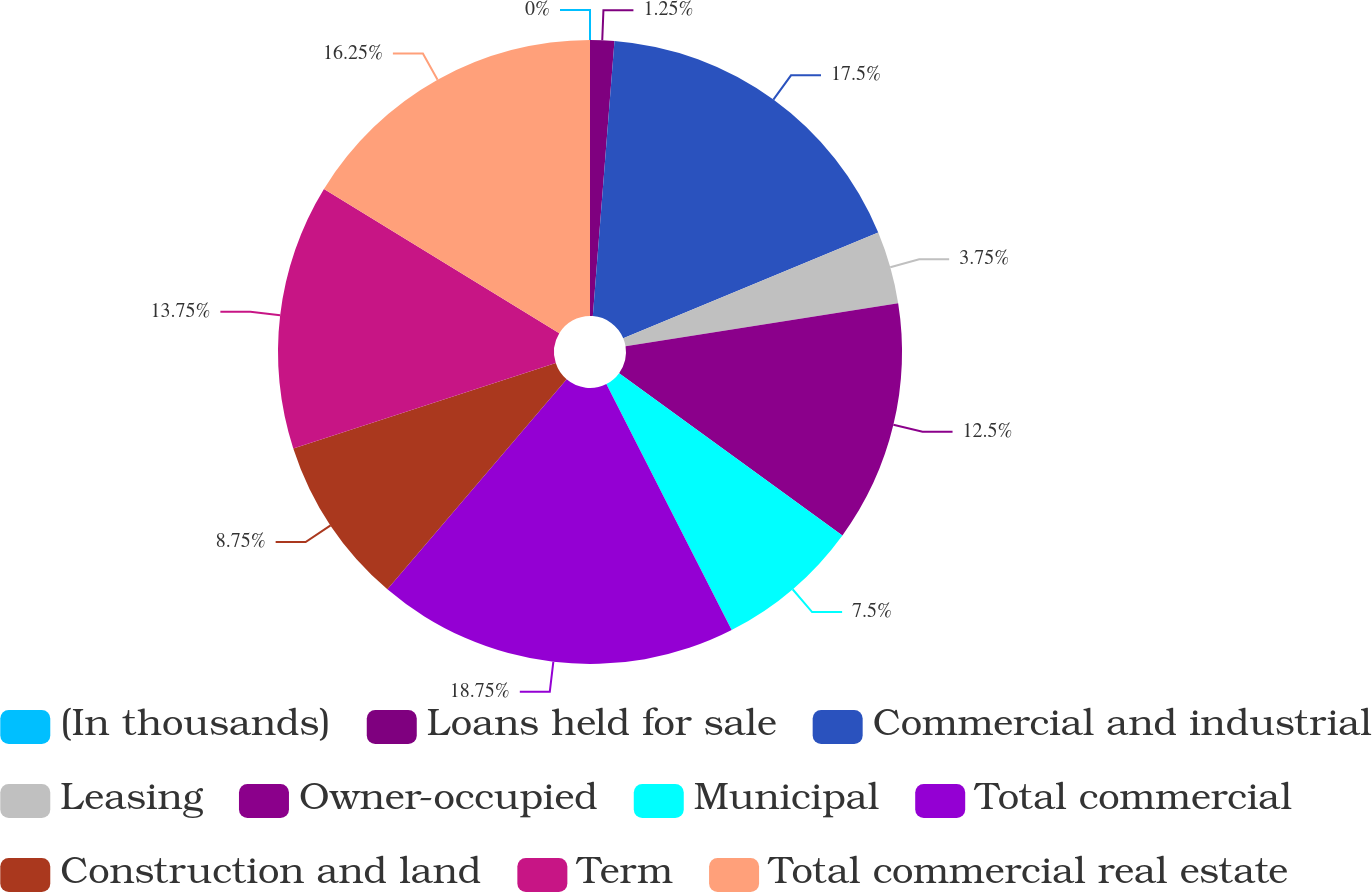<chart> <loc_0><loc_0><loc_500><loc_500><pie_chart><fcel>(In thousands)<fcel>Loans held for sale<fcel>Commercial and industrial<fcel>Leasing<fcel>Owner-occupied<fcel>Municipal<fcel>Total commercial<fcel>Construction and land<fcel>Term<fcel>Total commercial real estate<nl><fcel>0.0%<fcel>1.25%<fcel>17.5%<fcel>3.75%<fcel>12.5%<fcel>7.5%<fcel>18.75%<fcel>8.75%<fcel>13.75%<fcel>16.25%<nl></chart> 